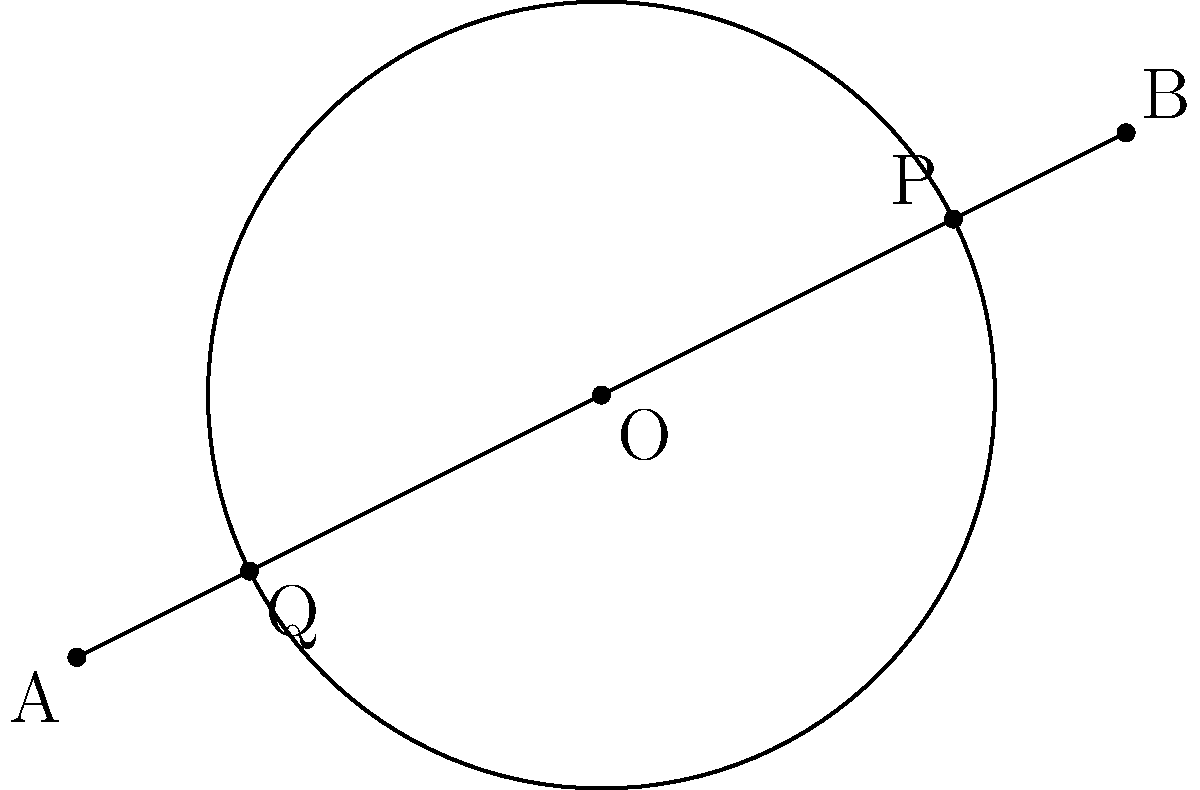In the financial market, a circular trading pattern with radius 3 units is centered at the origin (0,0). A trend line passes through points A(-4,-2) and B(4,2). Find the coordinates of the intersection points P and Q between the circle and the line. How might these intersection points be interpreted in terms of market entry and exit strategies? Let's approach this step-by-step:

1) The equation of the circle is:
   $$x^2 + y^2 = 3^2 = 9$$

2) To find the equation of the line, we can use the point-slope form:
   $$y - y_1 = m(x - x_1)$$
   where $m$ is the slope of the line.

3) Calculate the slope:
   $$m = \frac{y_2 - y_1}{x_2 - x_1} = \frac{2 - (-2)}{4 - (-4)} = \frac{4}{8} = \frac{1}{2}$$

4) Using point A(-4,-2), the equation of the line is:
   $$y - (-2) = \frac{1}{2}(x - (-4))$$
   $$y + 2 = \frac{1}{2}(x + 4)$$
   $$y = \frac{1}{2}x + 1$$

5) To find the intersection points, substitute the line equation into the circle equation:
   $$x^2 + (\frac{1}{2}x + 1)^2 = 9$$

6) Expand and simplify:
   $$x^2 + \frac{1}{4}x^2 + x + 1 = 9$$
   $$\frac{5}{4}x^2 + x - 8 = 0$$

7) Multiply by 4 to eliminate fractions:
   $$5x^2 + 4x - 32 = 0$$

8) Use the quadratic formula to solve:
   $$x = \frac{-b \pm \sqrt{b^2 - 4ac}}{2a}$$
   where $a=5$, $b=4$, and $c=-32$

9) Solving:
   $$x = \frac{-4 \pm \sqrt{16 + 640}}{10} = \frac{-4 \pm \sqrt{656}}{10} = \frac{-4 \pm 25.61}{10}$$

10) This gives us:
    $$x_1 = \frac{-4 + 25.61}{10} = 2.161$$
    $$x_2 = \frac{-4 - 25.61}{10} = -2.961$$

11) Substitute these x-values back into the line equation to find y:
    For $x_1$: $y = \frac{1}{2}(2.161) + 1 = 2.0805$
    For $x_2$: $y = \frac{1}{2}(-2.961) + 1 = -0.4805$

Therefore, the intersection points are approximately P(2.161, 2.0805) and Q(-2.961, -0.4805).

In terms of market strategies, these points could represent optimal entry (lower point) and exit (higher point) positions in a bullish trend, considering both the overall trend (line) and cyclical patterns (circle).
Answer: P(2.161, 2.0805) and Q(-2.961, -0.4805) 